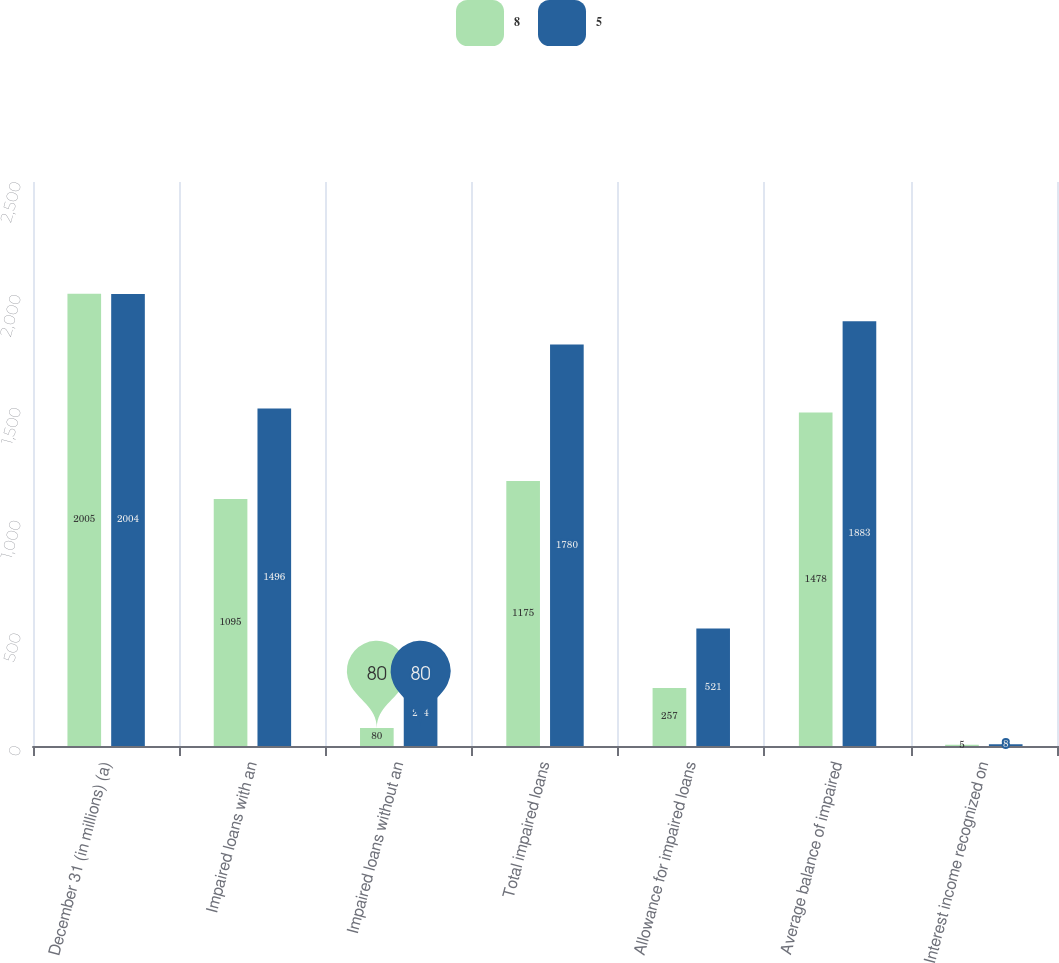<chart> <loc_0><loc_0><loc_500><loc_500><stacked_bar_chart><ecel><fcel>December 31 (in millions) (a)<fcel>Impaired loans with an<fcel>Impaired loans without an<fcel>Total impaired loans<fcel>Allowance for impaired loans<fcel>Average balance of impaired<fcel>Interest income recognized on<nl><fcel>8<fcel>2005<fcel>1095<fcel>80<fcel>1175<fcel>257<fcel>1478<fcel>5<nl><fcel>5<fcel>2004<fcel>1496<fcel>284<fcel>1780<fcel>521<fcel>1883<fcel>8<nl></chart> 